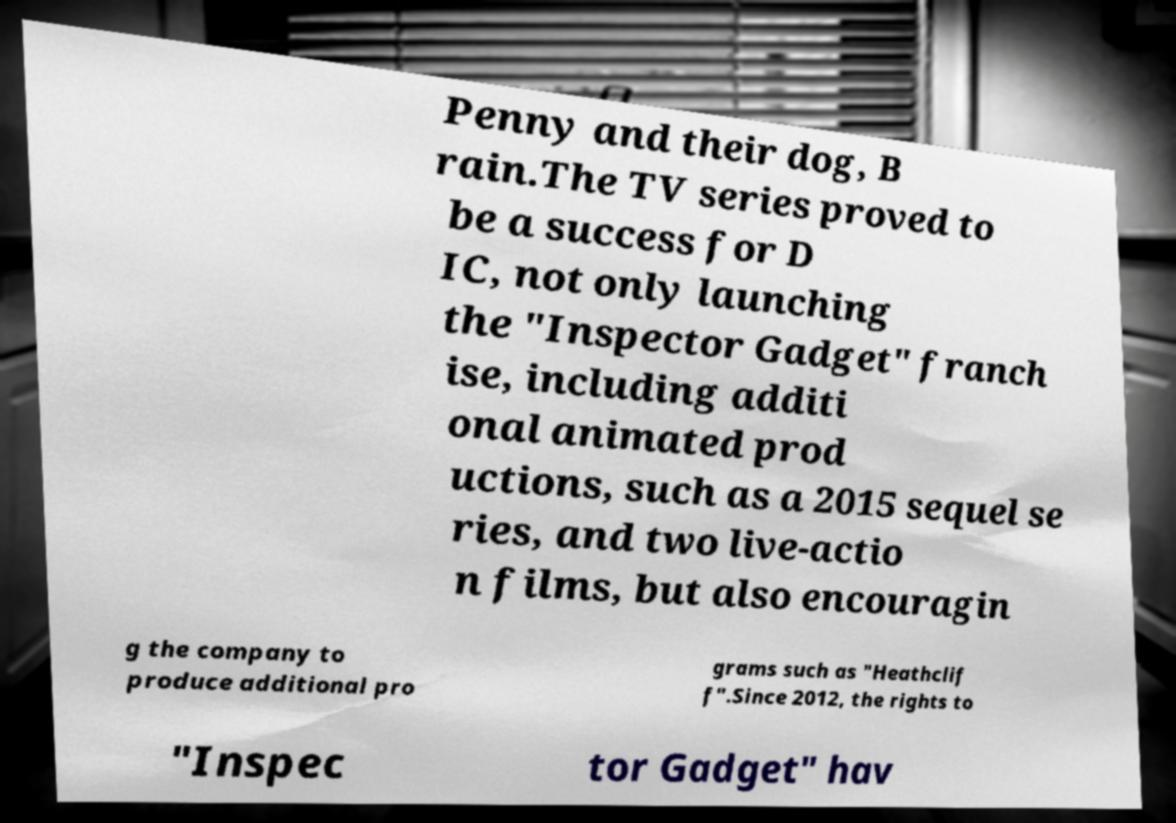Can you read and provide the text displayed in the image?This photo seems to have some interesting text. Can you extract and type it out for me? Penny and their dog, B rain.The TV series proved to be a success for D IC, not only launching the "Inspector Gadget" franch ise, including additi onal animated prod uctions, such as a 2015 sequel se ries, and two live-actio n films, but also encouragin g the company to produce additional pro grams such as "Heathclif f".Since 2012, the rights to "Inspec tor Gadget" hav 